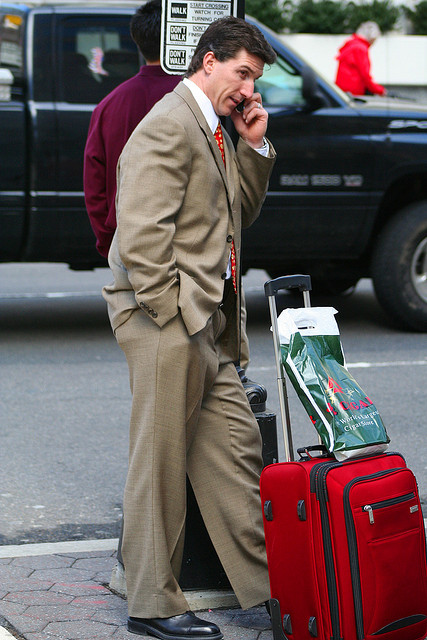Read and extract the text from this image. WALK WALK WALK Work 